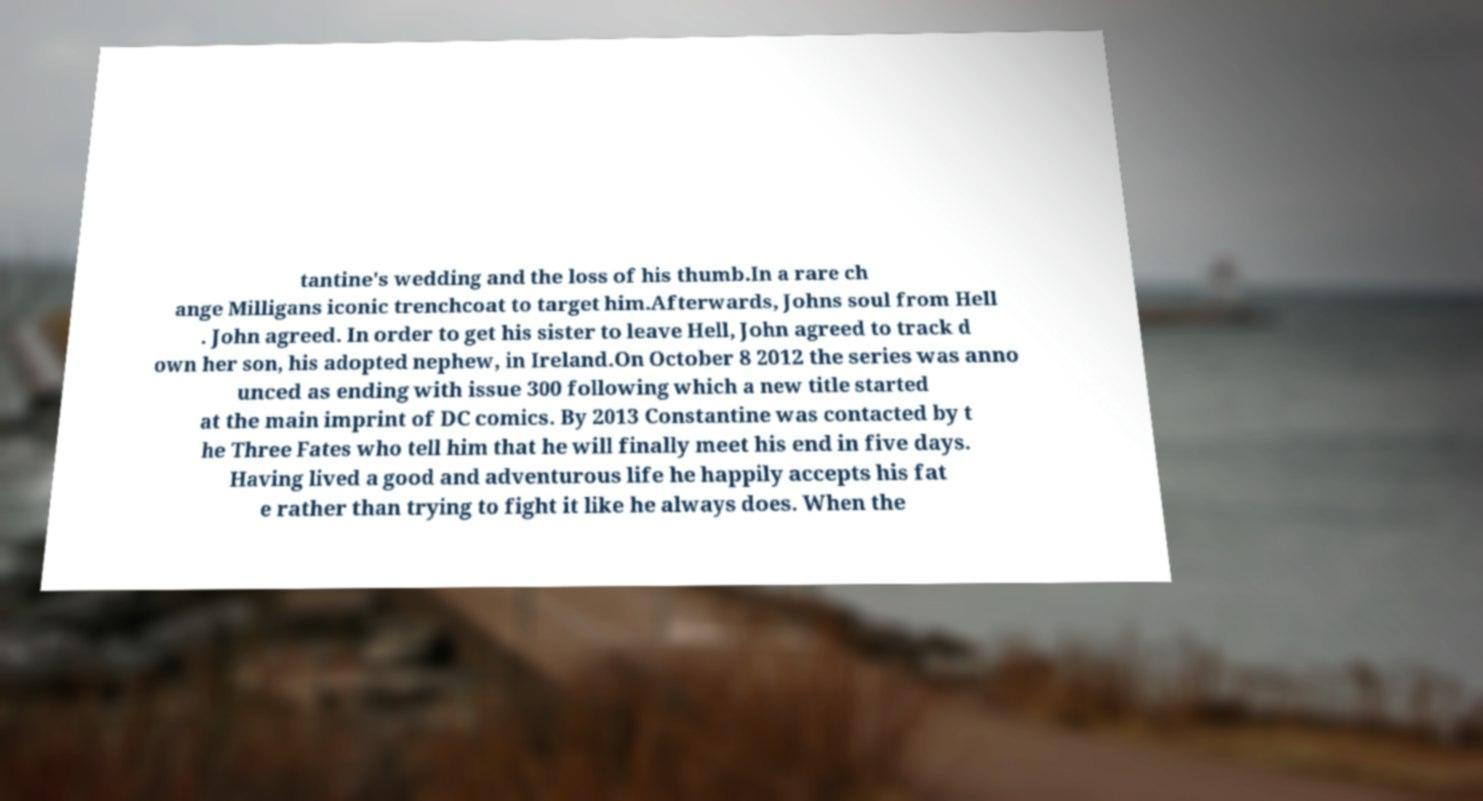There's text embedded in this image that I need extracted. Can you transcribe it verbatim? tantine's wedding and the loss of his thumb.In a rare ch ange Milligans iconic trenchcoat to target him.Afterwards, Johns soul from Hell . John agreed. In order to get his sister to leave Hell, John agreed to track d own her son, his adopted nephew, in Ireland.On October 8 2012 the series was anno unced as ending with issue 300 following which a new title started at the main imprint of DC comics. By 2013 Constantine was contacted by t he Three Fates who tell him that he will finally meet his end in five days. Having lived a good and adventurous life he happily accepts his fat e rather than trying to fight it like he always does. When the 